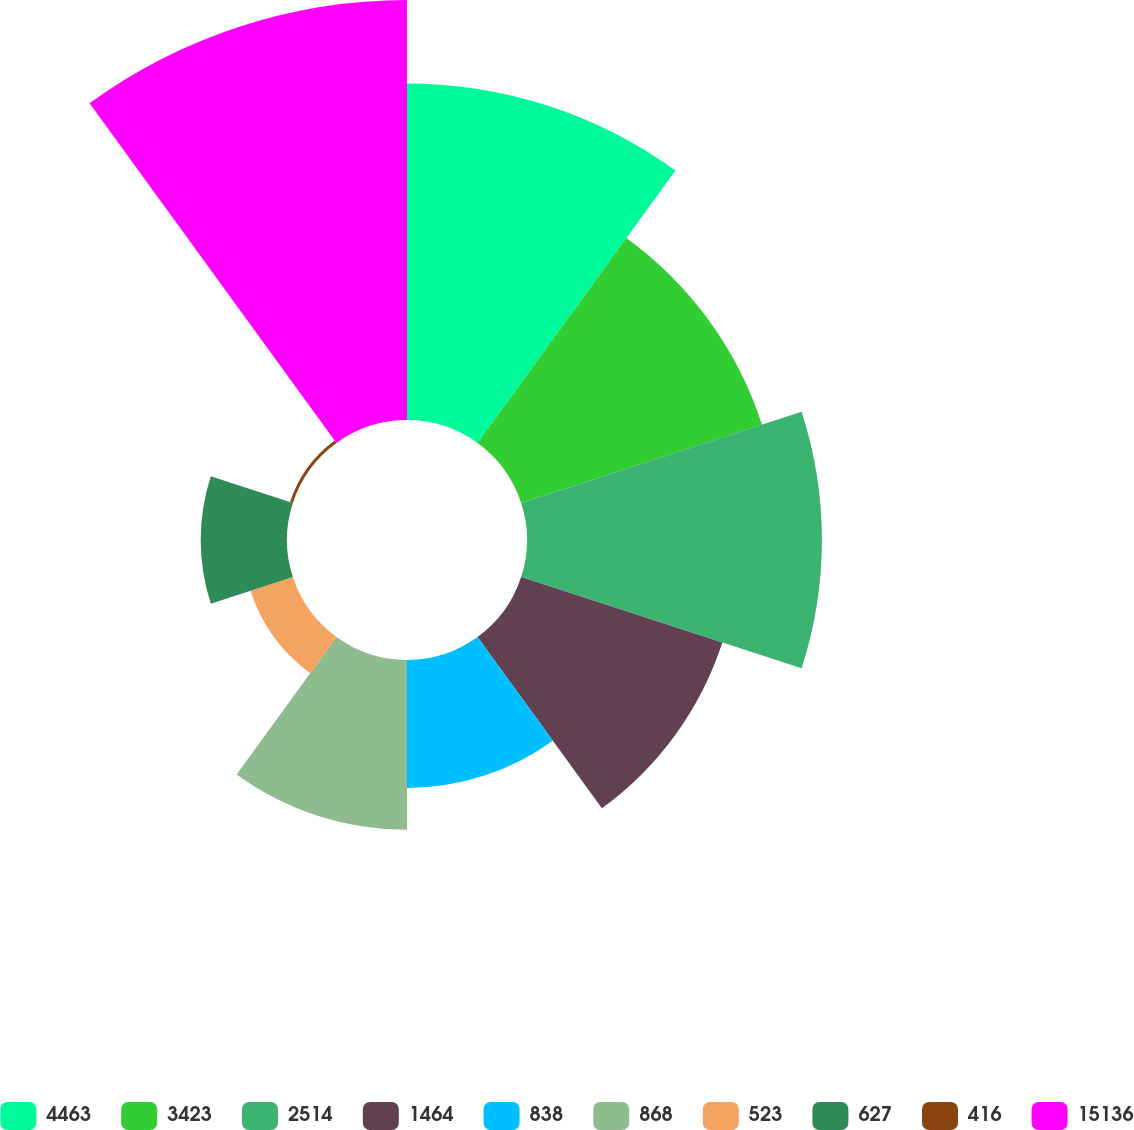Convert chart. <chart><loc_0><loc_0><loc_500><loc_500><pie_chart><fcel>4463<fcel>3423<fcel>2514<fcel>1464<fcel>838<fcel>868<fcel>523<fcel>627<fcel>416<fcel>15136<nl><fcel>17.28%<fcel>13.0%<fcel>15.14%<fcel>10.86%<fcel>6.57%<fcel>8.72%<fcel>2.29%<fcel>4.43%<fcel>0.15%<fcel>21.56%<nl></chart> 